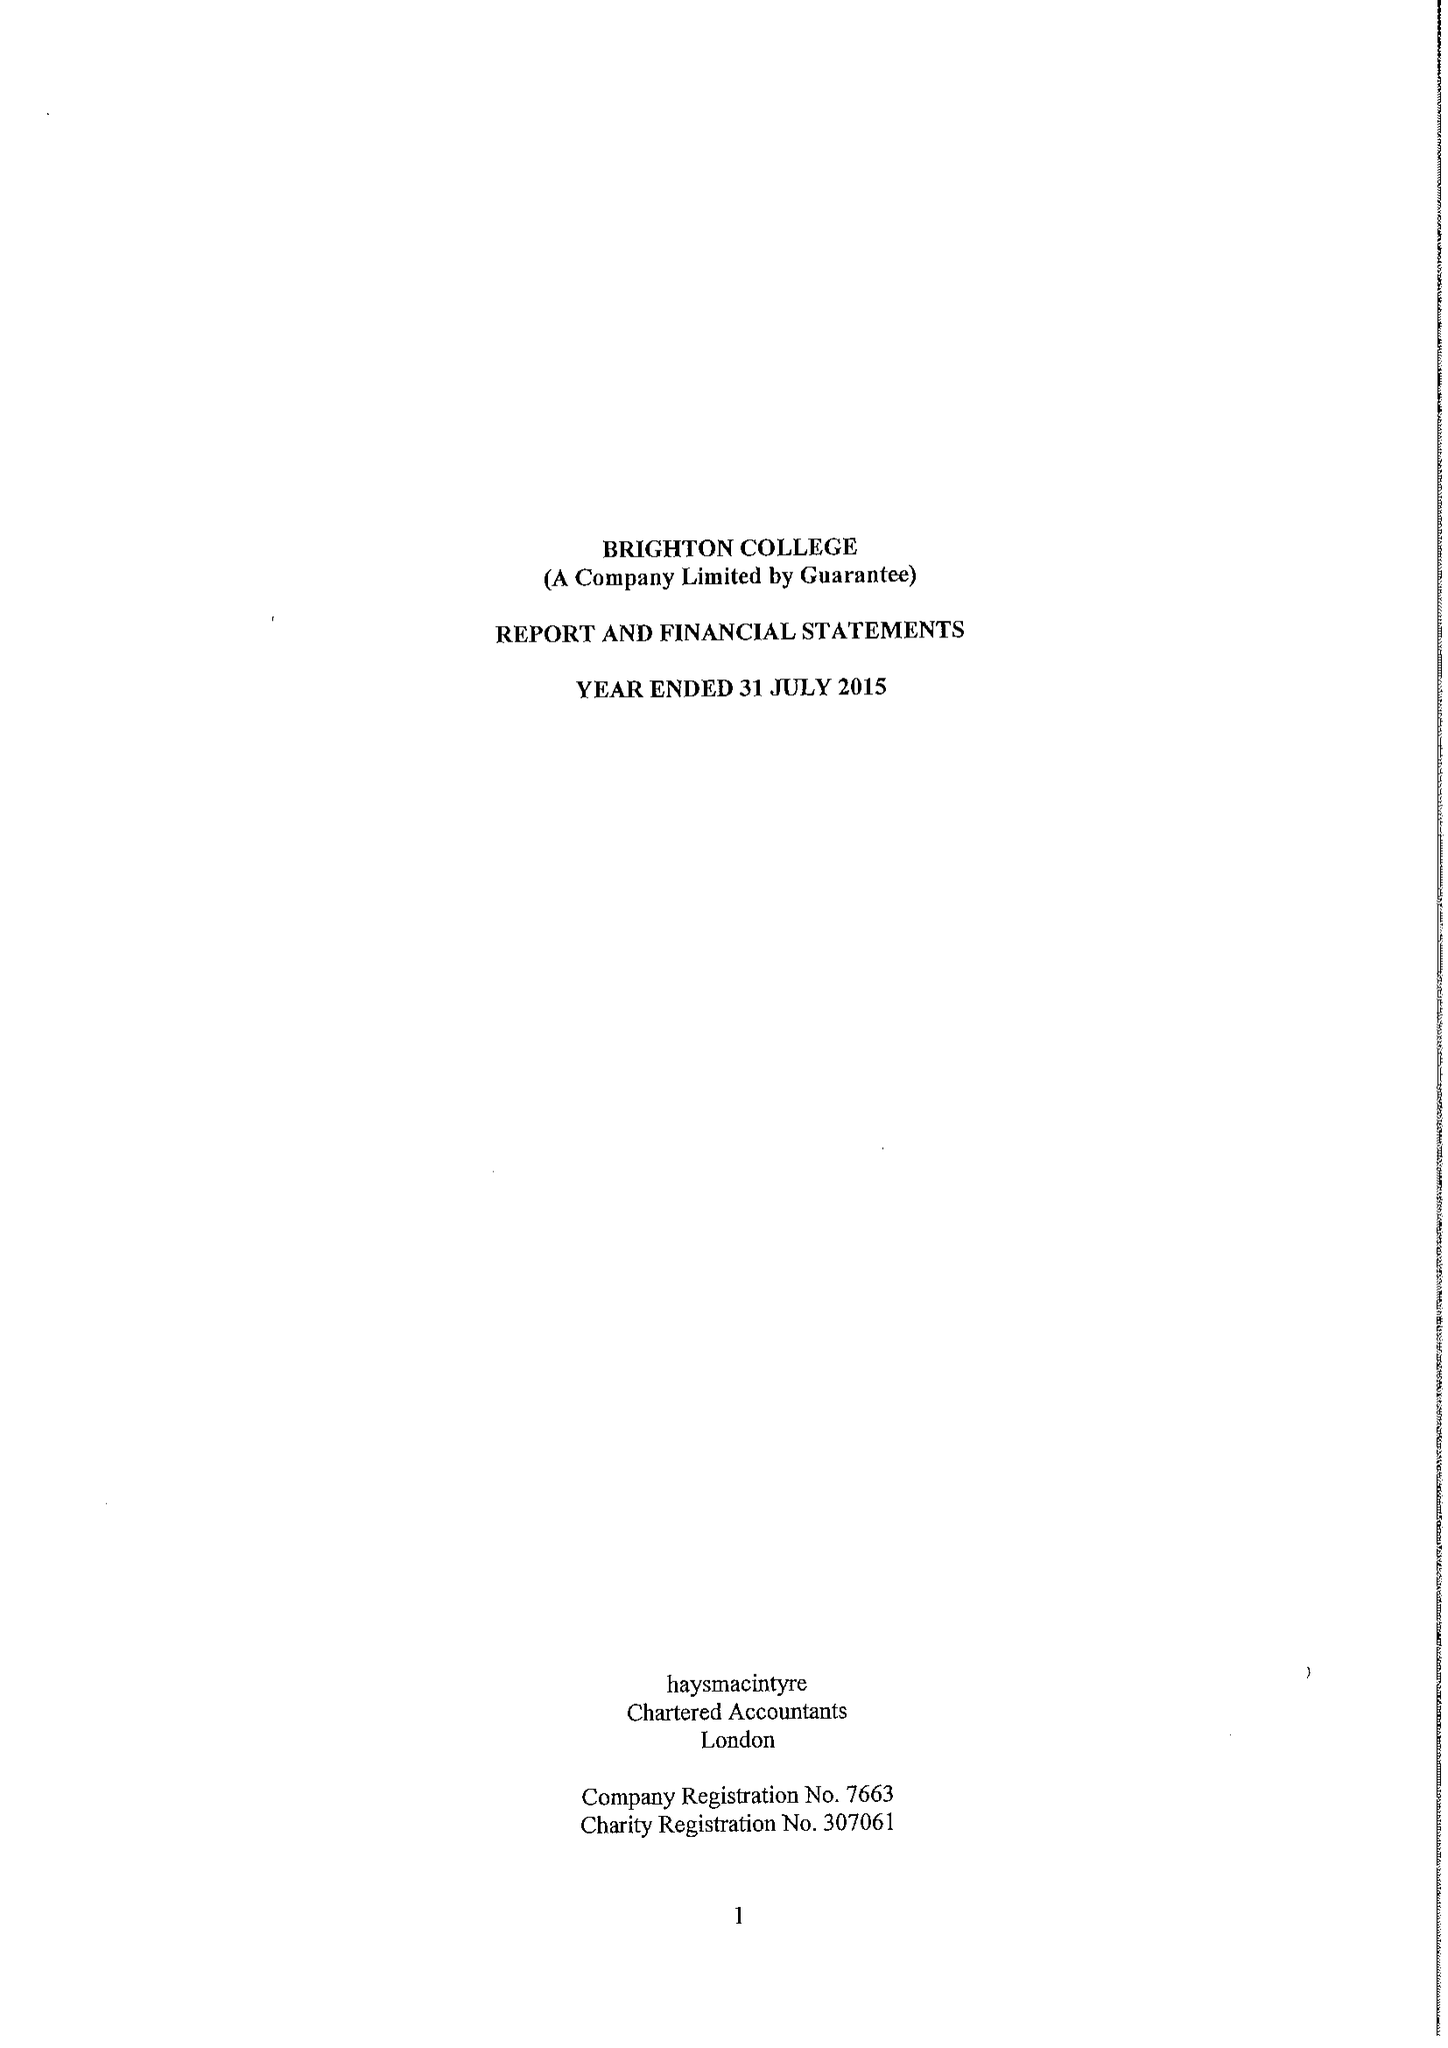What is the value for the report_date?
Answer the question using a single word or phrase. 2015-07-31 